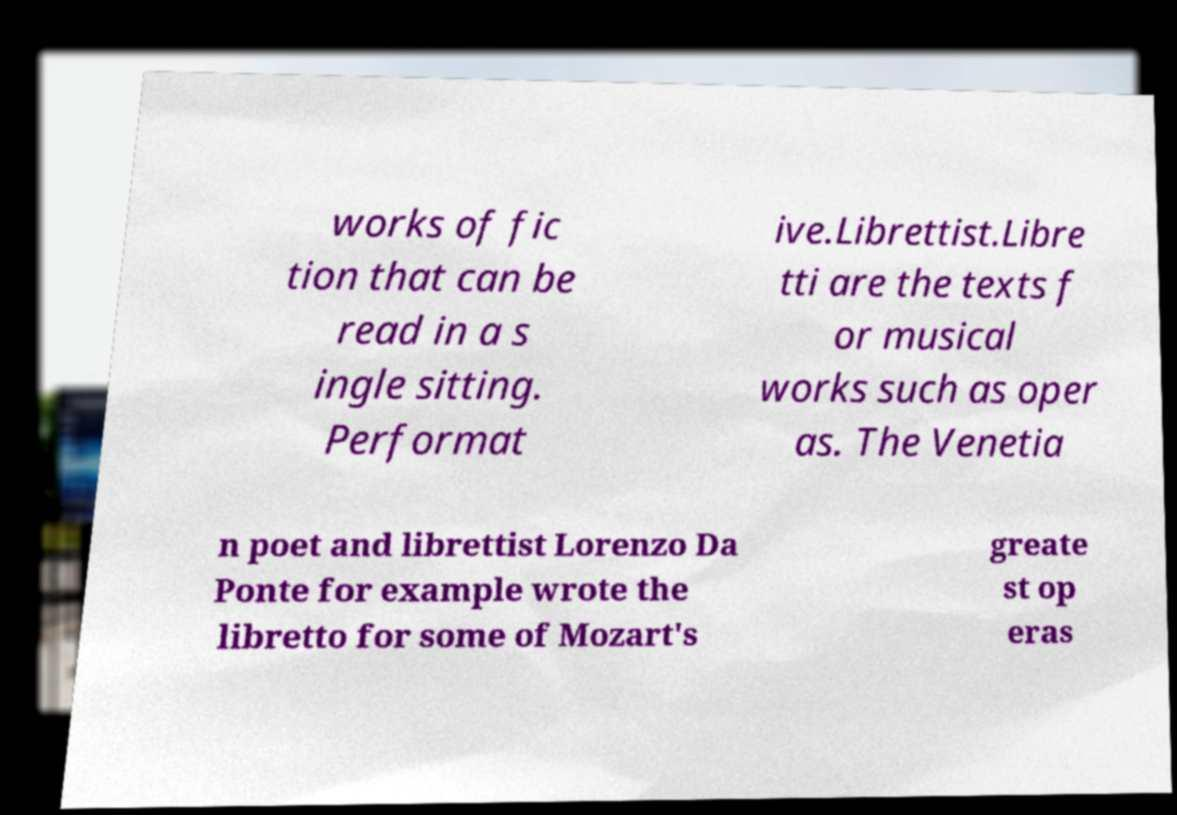Please identify and transcribe the text found in this image. works of fic tion that can be read in a s ingle sitting. Performat ive.Librettist.Libre tti are the texts f or musical works such as oper as. The Venetia n poet and librettist Lorenzo Da Ponte for example wrote the libretto for some of Mozart's greate st op eras 